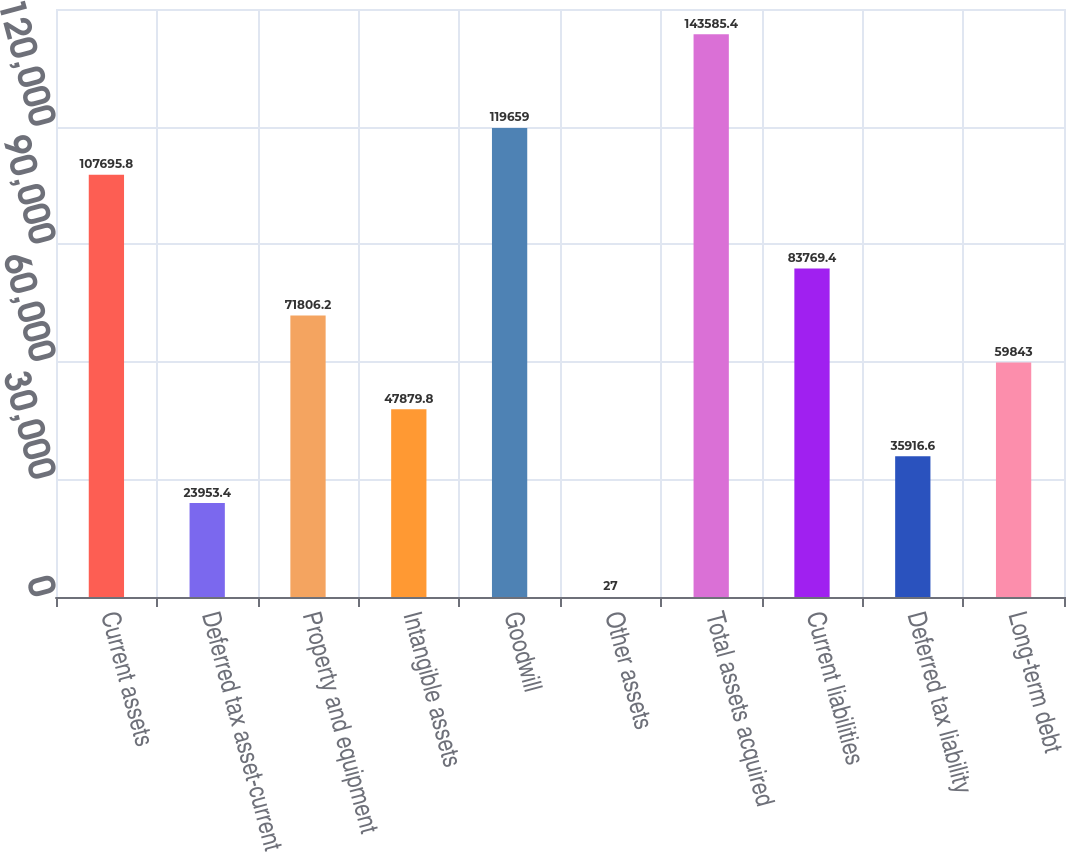Convert chart to OTSL. <chart><loc_0><loc_0><loc_500><loc_500><bar_chart><fcel>Current assets<fcel>Deferred tax asset-current<fcel>Property and equipment<fcel>Intangible assets<fcel>Goodwill<fcel>Other assets<fcel>Total assets acquired<fcel>Current liabilities<fcel>Deferred tax liability<fcel>Long-term debt<nl><fcel>107696<fcel>23953.4<fcel>71806.2<fcel>47879.8<fcel>119659<fcel>27<fcel>143585<fcel>83769.4<fcel>35916.6<fcel>59843<nl></chart> 